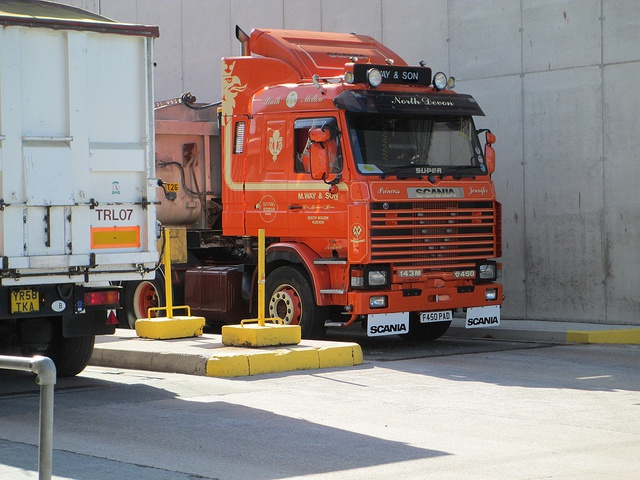Describe the objects in this image and their specific colors. I can see truck in gray, black, brown, and red tones and truck in gray, lightgray, darkgray, and black tones in this image. 